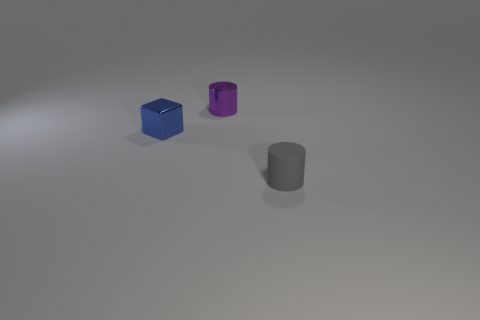Subtract all cylinders. How many objects are left? 1 Subtract all yellow balls. How many red cubes are left? 0 Add 3 purple metallic cylinders. How many purple metallic cylinders are left? 4 Add 2 small spheres. How many small spheres exist? 2 Add 3 metal cylinders. How many objects exist? 6 Subtract 0 yellow cylinders. How many objects are left? 3 Subtract all yellow cylinders. Subtract all purple balls. How many cylinders are left? 2 Subtract all gray rubber cylinders. Subtract all small purple shiny cylinders. How many objects are left? 1 